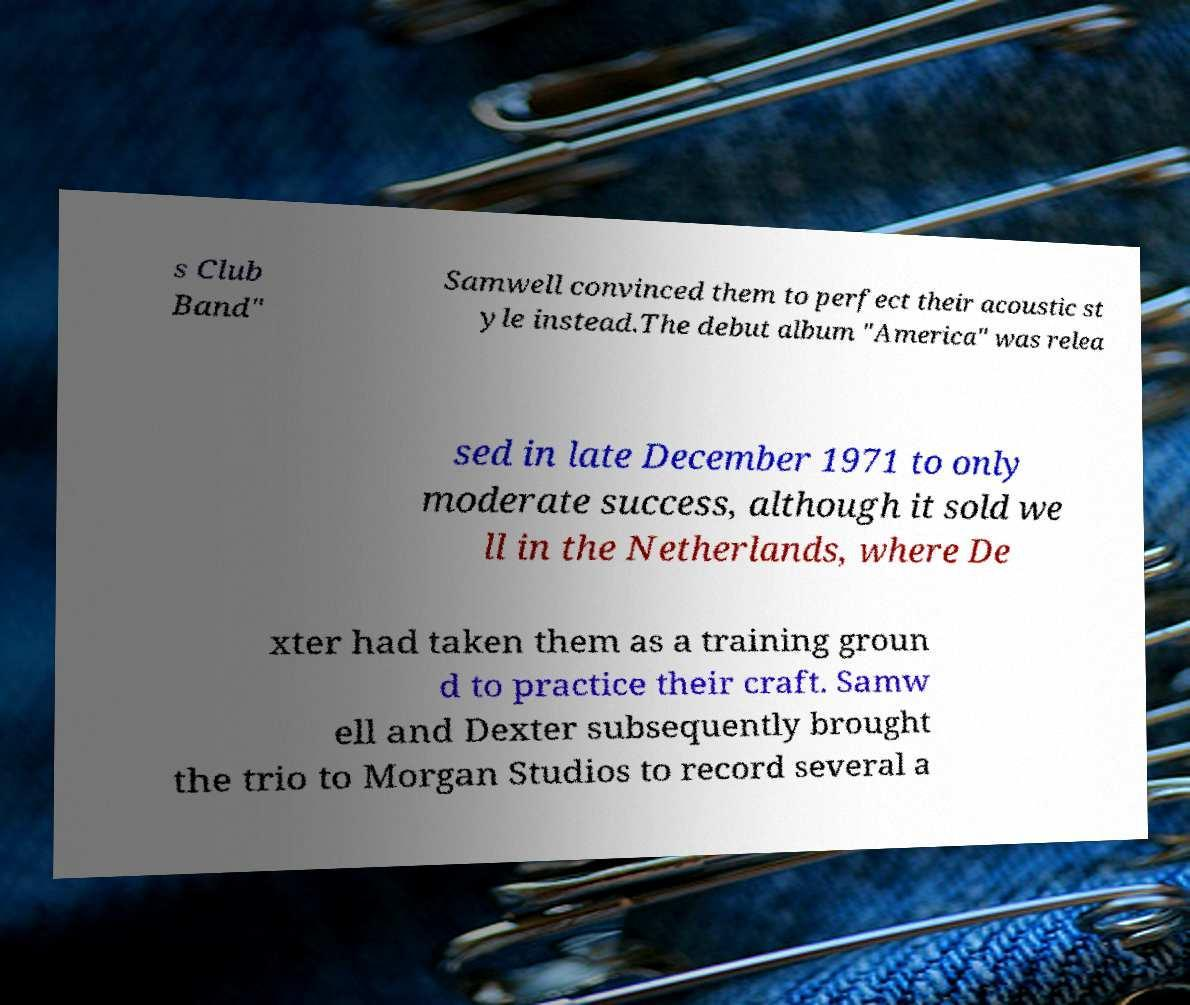Could you assist in decoding the text presented in this image and type it out clearly? s Club Band" Samwell convinced them to perfect their acoustic st yle instead.The debut album "America" was relea sed in late December 1971 to only moderate success, although it sold we ll in the Netherlands, where De xter had taken them as a training groun d to practice their craft. Samw ell and Dexter subsequently brought the trio to Morgan Studios to record several a 